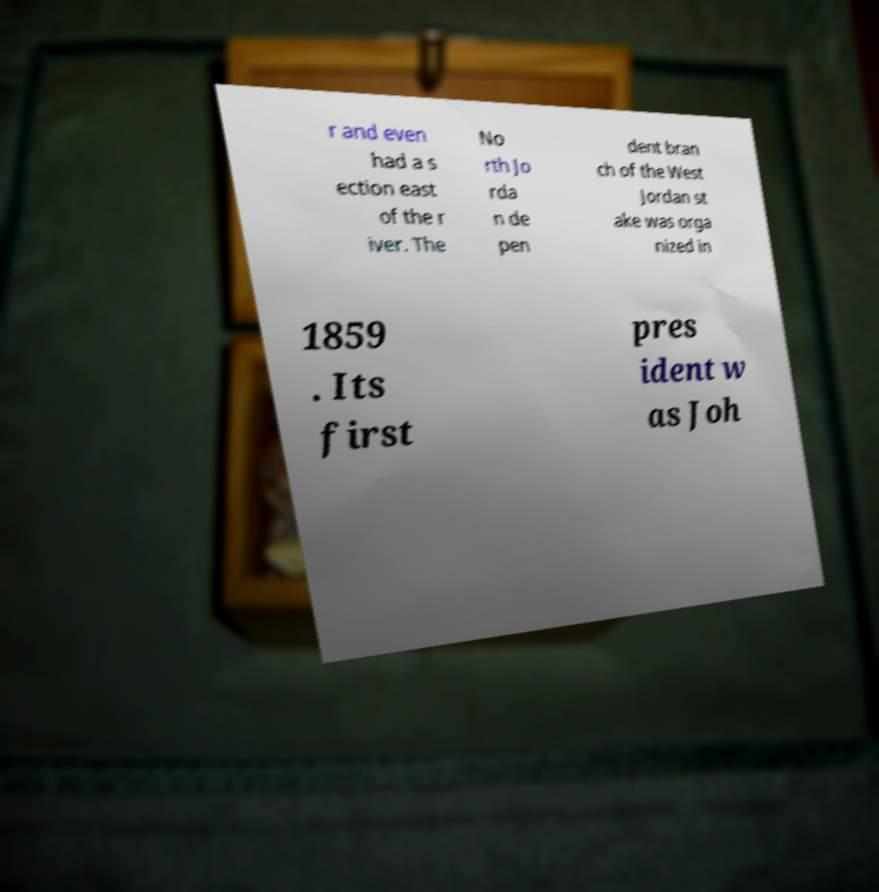Could you assist in decoding the text presented in this image and type it out clearly? r and even had a s ection east of the r iver. The No rth Jo rda n de pen dent bran ch of the West Jordan st ake was orga nized in 1859 . Its first pres ident w as Joh 